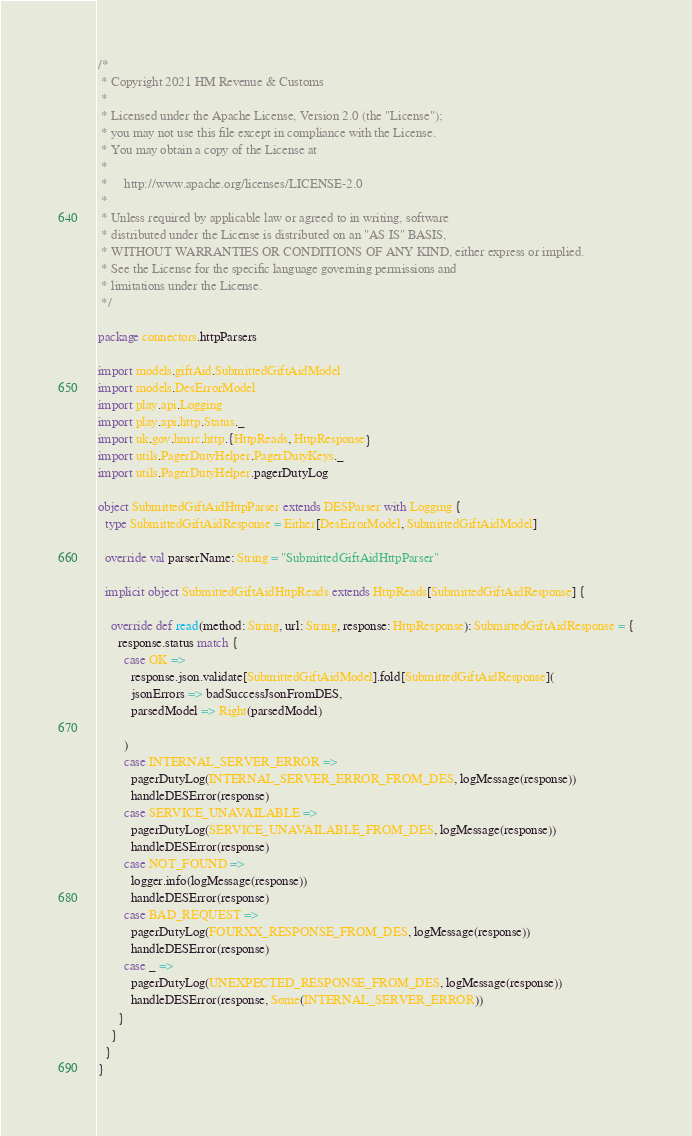<code> <loc_0><loc_0><loc_500><loc_500><_Scala_>/*
 * Copyright 2021 HM Revenue & Customs
 *
 * Licensed under the Apache License, Version 2.0 (the "License");
 * you may not use this file except in compliance with the License.
 * You may obtain a copy of the License at
 *
 *     http://www.apache.org/licenses/LICENSE-2.0
 *
 * Unless required by applicable law or agreed to in writing, software
 * distributed under the License is distributed on an "AS IS" BASIS,
 * WITHOUT WARRANTIES OR CONDITIONS OF ANY KIND, either express or implied.
 * See the License for the specific language governing permissions and
 * limitations under the License.
 */

package connectors.httpParsers

import models.giftAid.SubmittedGiftAidModel
import models.DesErrorModel
import play.api.Logging
import play.api.http.Status._
import uk.gov.hmrc.http.{HttpReads, HttpResponse}
import utils.PagerDutyHelper.PagerDutyKeys._
import utils.PagerDutyHelper.pagerDutyLog

object SubmittedGiftAidHttpParser extends DESParser with Logging {
  type SubmittedGiftAidResponse = Either[DesErrorModel, SubmittedGiftAidModel]

  override val parserName: String = "SubmittedGiftAidHttpParser"

  implicit object SubmittedGiftAidHttpReads extends HttpReads[SubmittedGiftAidResponse] {

    override def read(method: String, url: String, response: HttpResponse): SubmittedGiftAidResponse = {
      response.status match {
        case OK =>
          response.json.validate[SubmittedGiftAidModel].fold[SubmittedGiftAidResponse](
          jsonErrors => badSuccessJsonFromDES,
          parsedModel => Right(parsedModel)

        )
        case INTERNAL_SERVER_ERROR =>
          pagerDutyLog(INTERNAL_SERVER_ERROR_FROM_DES, logMessage(response))
          handleDESError(response)
        case SERVICE_UNAVAILABLE =>
          pagerDutyLog(SERVICE_UNAVAILABLE_FROM_DES, logMessage(response))
          handleDESError(response)
        case NOT_FOUND =>
          logger.info(logMessage(response))
          handleDESError(response)
        case BAD_REQUEST =>
          pagerDutyLog(FOURXX_RESPONSE_FROM_DES, logMessage(response))
          handleDESError(response)
        case _ =>
          pagerDutyLog(UNEXPECTED_RESPONSE_FROM_DES, logMessage(response))
          handleDESError(response, Some(INTERNAL_SERVER_ERROR))
      }
    }
  }
}
</code> 